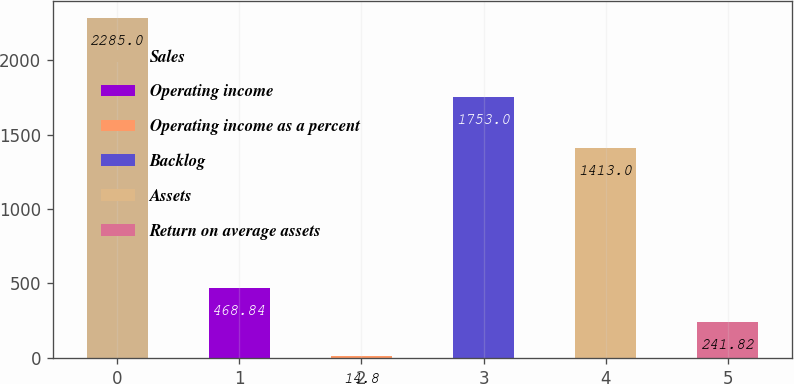<chart> <loc_0><loc_0><loc_500><loc_500><bar_chart><fcel>Sales<fcel>Operating income<fcel>Operating income as a percent<fcel>Backlog<fcel>Assets<fcel>Return on average assets<nl><fcel>2285<fcel>468.84<fcel>14.8<fcel>1753<fcel>1413<fcel>241.82<nl></chart> 